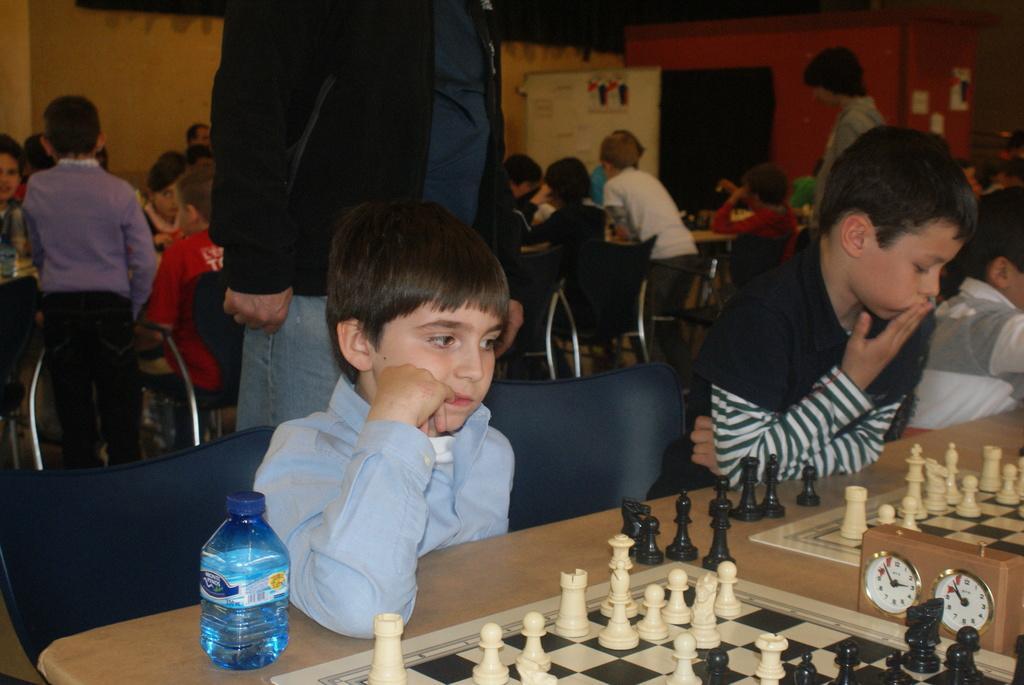Could you give a brief overview of what you see in this image? In this image I can see of people some are standing and some are sitting, the person in front is sitting and the person is wearing blue color shirt and the person at right is wearing black and white color shirt. I can also see few chess coins and boars on the table. 